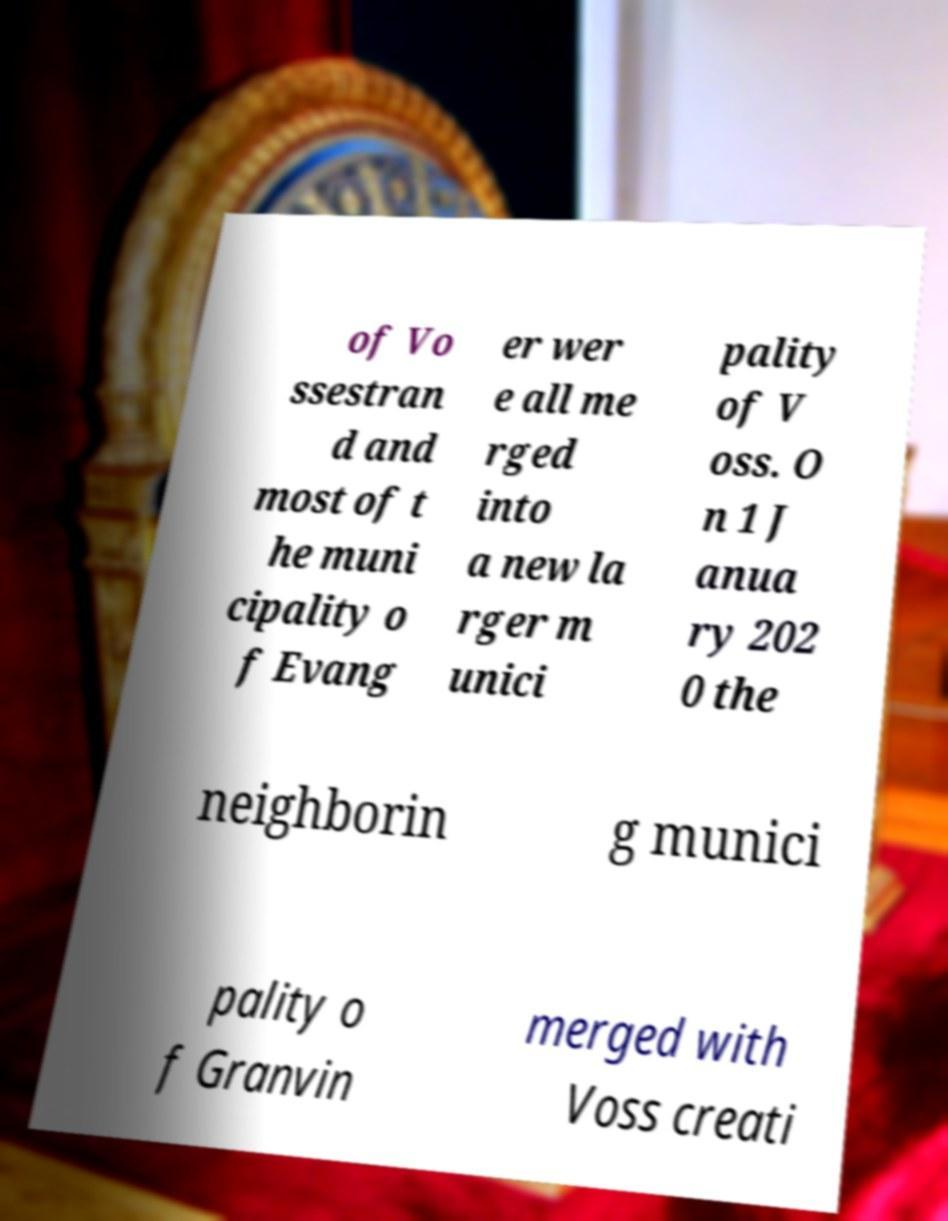I need the written content from this picture converted into text. Can you do that? of Vo ssestran d and most of t he muni cipality o f Evang er wer e all me rged into a new la rger m unici pality of V oss. O n 1 J anua ry 202 0 the neighborin g munici pality o f Granvin merged with Voss creati 